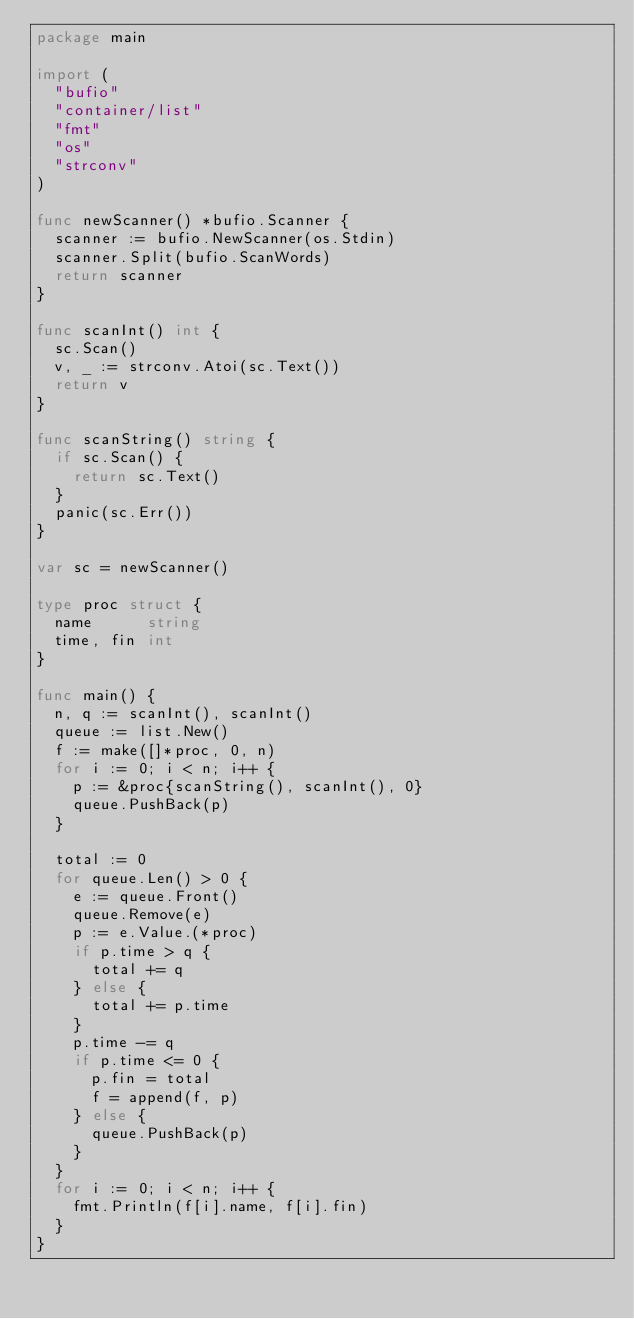Convert code to text. <code><loc_0><loc_0><loc_500><loc_500><_Go_>package main

import (
	"bufio"
	"container/list"
	"fmt"
	"os"
	"strconv"
)

func newScanner() *bufio.Scanner {
	scanner := bufio.NewScanner(os.Stdin)
	scanner.Split(bufio.ScanWords)
	return scanner
}

func scanInt() int {
	sc.Scan()
	v, _ := strconv.Atoi(sc.Text())
	return v
}

func scanString() string {
	if sc.Scan() {
		return sc.Text()
	}
	panic(sc.Err())
}

var sc = newScanner()

type proc struct {
	name      string
	time, fin int
}

func main() {
	n, q := scanInt(), scanInt()
	queue := list.New()
	f := make([]*proc, 0, n)
	for i := 0; i < n; i++ {
		p := &proc{scanString(), scanInt(), 0}
		queue.PushBack(p)
	}

	total := 0
	for queue.Len() > 0 {
		e := queue.Front()
		queue.Remove(e)
		p := e.Value.(*proc)
		if p.time > q {
			total += q
		} else {
			total += p.time
		}
		p.time -= q
		if p.time <= 0 {
			p.fin = total
			f = append(f, p)
		} else {
			queue.PushBack(p)
		}
	}
	for i := 0; i < n; i++ {
		fmt.Println(f[i].name, f[i].fin)
	}
}

</code> 